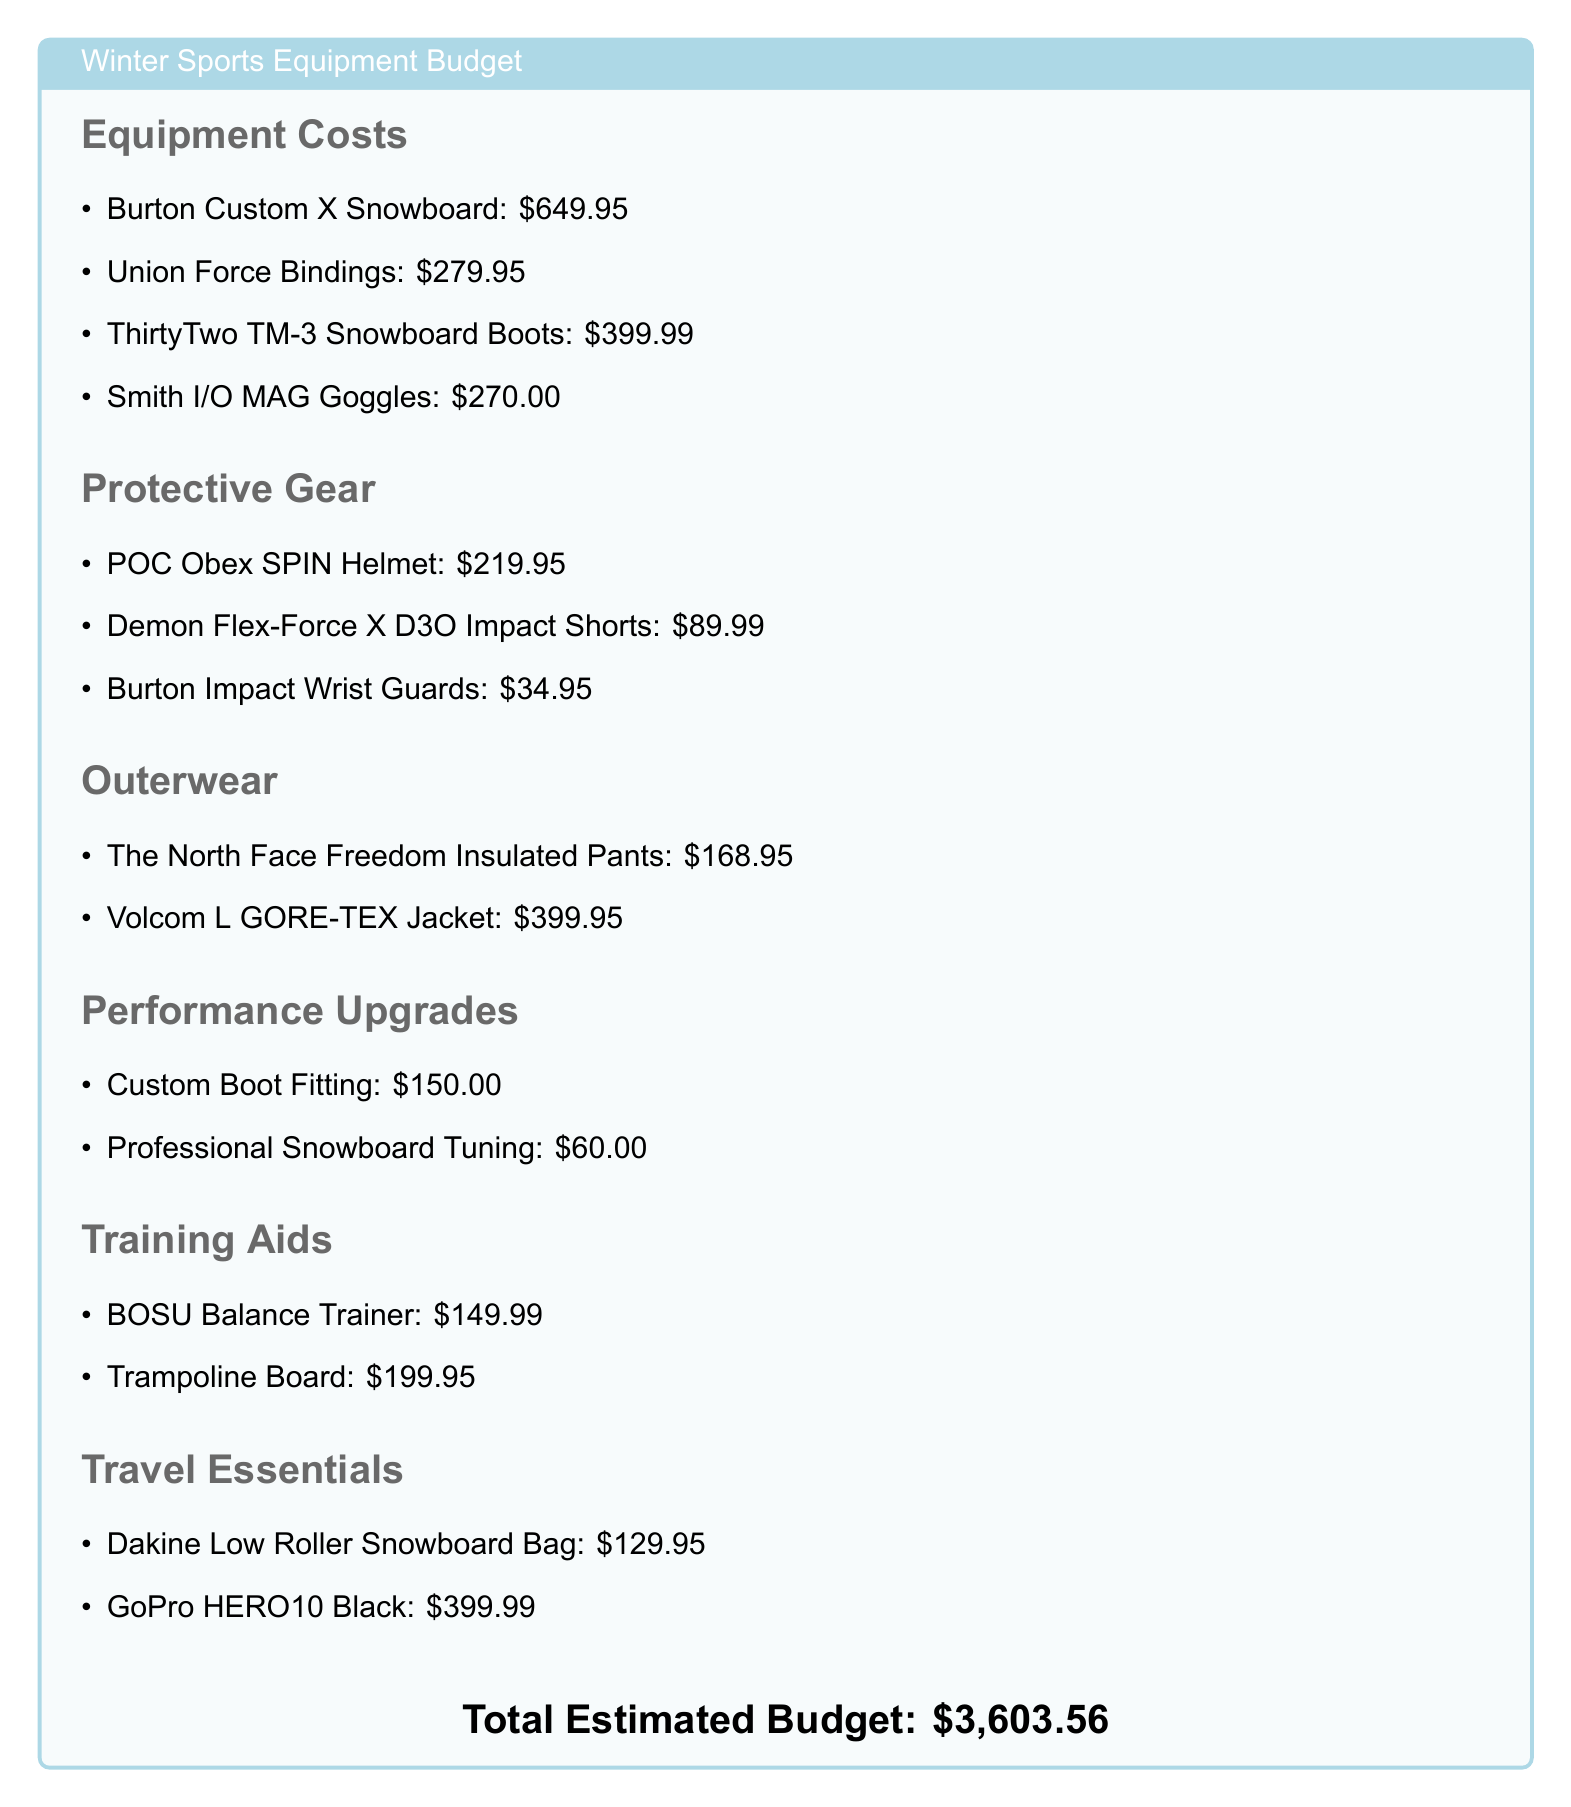what is the total estimated budget? The total estimated budget is presented at the bottom of the document.
Answer: $3,603.56 how much do the Burton Custom X Snowboard cost? The cost of the Burton Custom X Snowboard is listed under Equipment Costs.
Answer: $649.95 what is the price of the POC Obex SPIN Helmet? The price of the POC Obex SPIN Helmet is provided in the Protective Gear section.
Answer: $219.95 how much are the professional snowboard tuning services? The cost for professional snowboard tuning is mentioned under Performance Upgrades.
Answer: $60.00 which brand provides the insulated pants listed? The brand for the insulated pants is provided in the Outerwear section.
Answer: The North Face what is the cost of custom boot fitting? The cost for custom boot fitting is outlined in the Performance Upgrades section.
Answer: $150.00 which item is the most expensive in the Travel Essentials section? The most expensive item in the Travel Essentials section is identified among the two listed.
Answer: GoPro HERO10 Black how much do the gloves cost? The items associated with gloves are not mentioned in the document; thus, the answer is inferred.
Answer: Not mentioned 